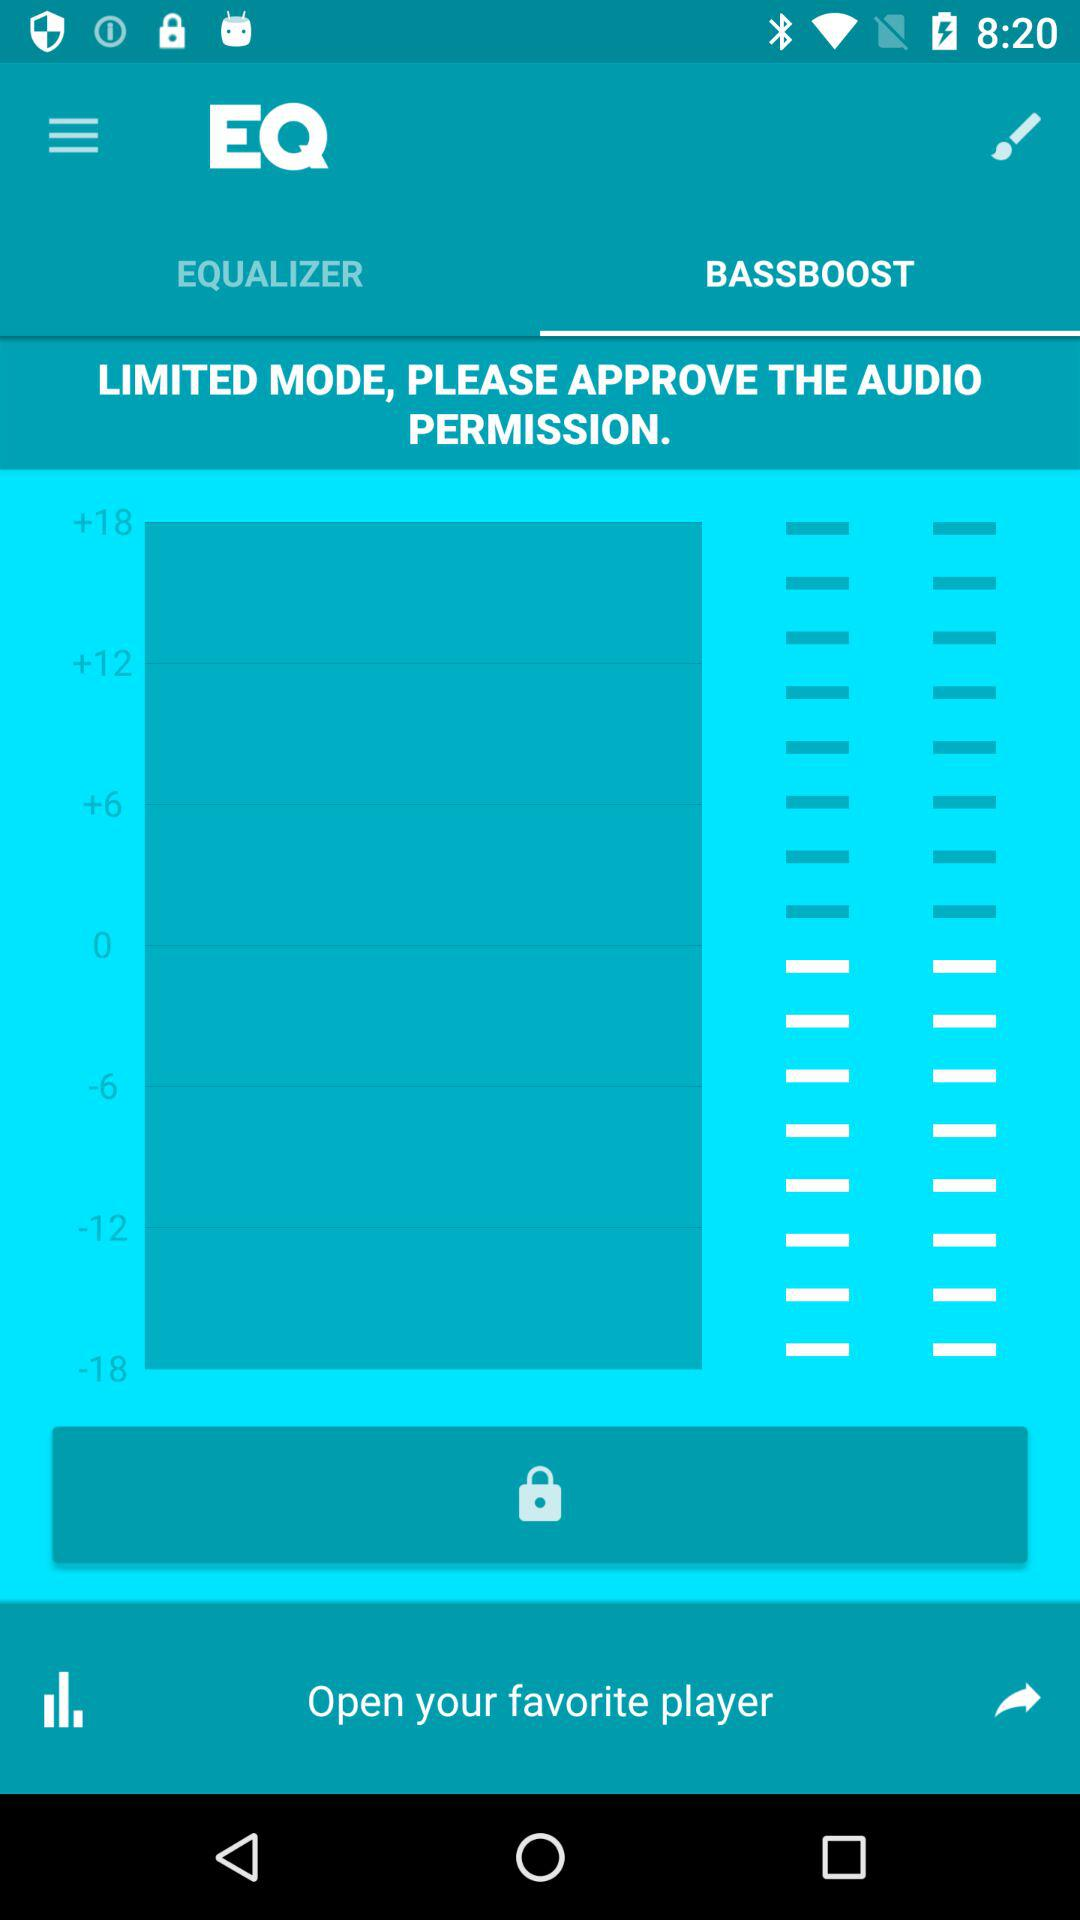Which tab is selected? The selected tab is "Bassboost". 